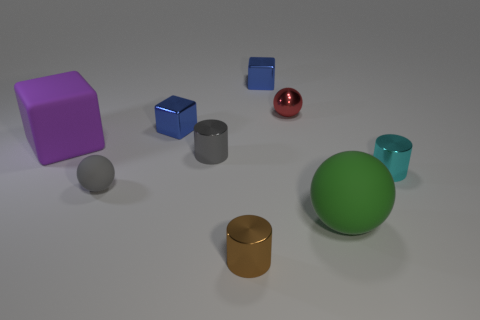Add 1 small red spheres. How many objects exist? 10 Subtract all blocks. How many objects are left? 6 Subtract 0 brown blocks. How many objects are left? 9 Subtract all large gray rubber balls. Subtract all small matte balls. How many objects are left? 8 Add 5 green rubber spheres. How many green rubber spheres are left? 6 Add 7 small rubber spheres. How many small rubber spheres exist? 8 